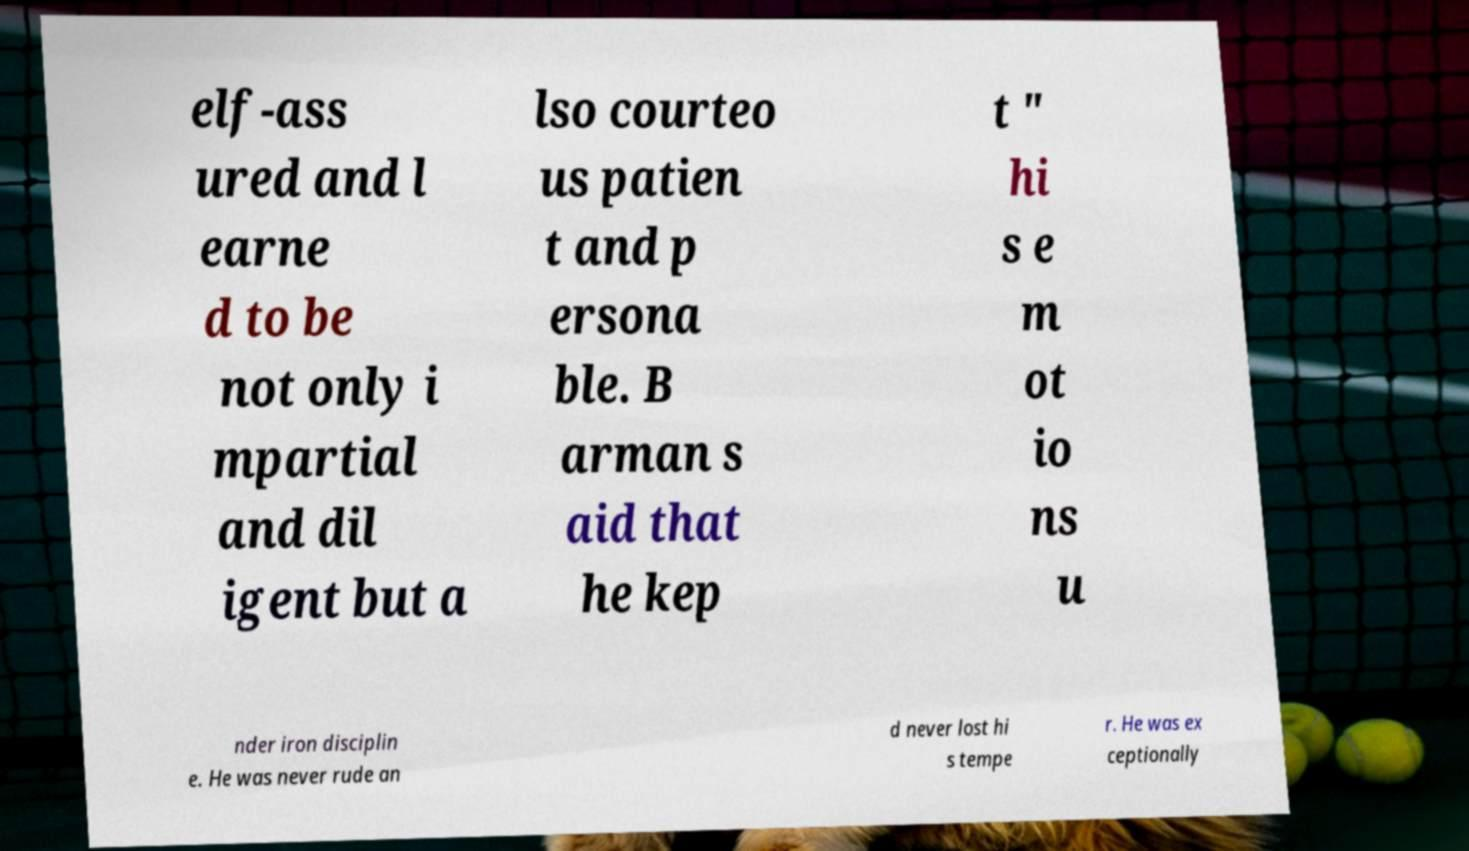What messages or text are displayed in this image? I need them in a readable, typed format. elf-ass ured and l earne d to be not only i mpartial and dil igent but a lso courteo us patien t and p ersona ble. B arman s aid that he kep t " hi s e m ot io ns u nder iron disciplin e. He was never rude an d never lost hi s tempe r. He was ex ceptionally 